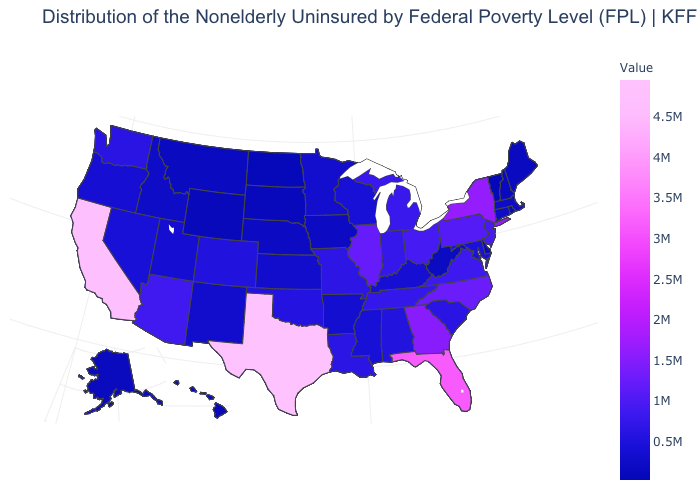Among the states that border Utah , which have the highest value?
Keep it brief. Arizona. Among the states that border Connecticut , which have the highest value?
Keep it brief. New York. Does Georgia have a higher value than Wyoming?
Keep it brief. Yes. Does New Mexico have a lower value than Texas?
Concise answer only. Yes. Does Louisiana have the highest value in the South?
Quick response, please. No. Among the states that border Oregon , does Nevada have the lowest value?
Be succinct. No. Does Texas have the highest value in the USA?
Keep it brief. Yes. 